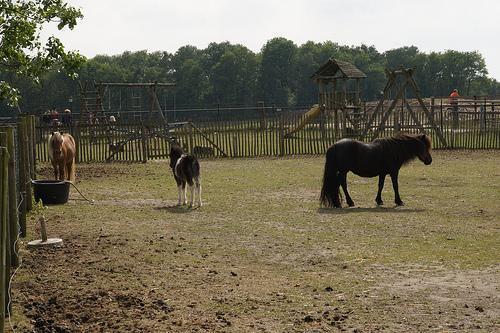How many dinosaurs are in the picture?
Give a very brief answer. 0. 